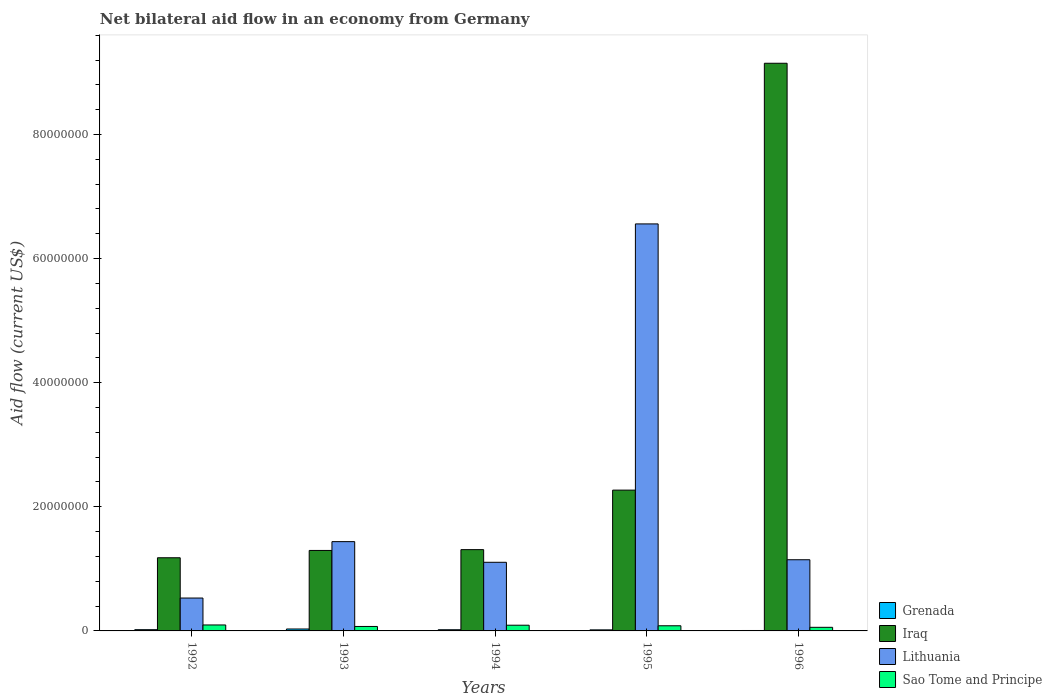How many different coloured bars are there?
Offer a terse response. 4. How many groups of bars are there?
Offer a very short reply. 5. Are the number of bars per tick equal to the number of legend labels?
Your answer should be very brief. Yes. How many bars are there on the 1st tick from the right?
Keep it short and to the point. 4. What is the label of the 1st group of bars from the left?
Keep it short and to the point. 1992. In how many cases, is the number of bars for a given year not equal to the number of legend labels?
Ensure brevity in your answer.  0. What is the net bilateral aid flow in Lithuania in 1994?
Provide a succinct answer. 1.11e+07. Across all years, what is the maximum net bilateral aid flow in Sao Tome and Principe?
Keep it short and to the point. 9.60e+05. Across all years, what is the minimum net bilateral aid flow in Sao Tome and Principe?
Offer a very short reply. 5.80e+05. What is the total net bilateral aid flow in Lithuania in the graph?
Provide a short and direct response. 1.08e+08. What is the difference between the net bilateral aid flow in Lithuania in 1994 and that in 1996?
Offer a very short reply. -4.10e+05. What is the difference between the net bilateral aid flow in Sao Tome and Principe in 1996 and the net bilateral aid flow in Grenada in 1994?
Give a very brief answer. 3.90e+05. What is the average net bilateral aid flow in Sao Tome and Principe per year?
Your response must be concise. 8.02e+05. In the year 1994, what is the difference between the net bilateral aid flow in Grenada and net bilateral aid flow in Sao Tome and Principe?
Keep it short and to the point. -7.30e+05. What is the ratio of the net bilateral aid flow in Lithuania in 1993 to that in 1996?
Your answer should be compact. 1.25. Is the net bilateral aid flow in Grenada in 1992 less than that in 1993?
Your response must be concise. Yes. Is the difference between the net bilateral aid flow in Grenada in 1994 and 1995 greater than the difference between the net bilateral aid flow in Sao Tome and Principe in 1994 and 1995?
Offer a very short reply. No. What is the difference between the highest and the second highest net bilateral aid flow in Lithuania?
Provide a short and direct response. 5.12e+07. What is the difference between the highest and the lowest net bilateral aid flow in Sao Tome and Principe?
Give a very brief answer. 3.80e+05. Is it the case that in every year, the sum of the net bilateral aid flow in Sao Tome and Principe and net bilateral aid flow in Lithuania is greater than the sum of net bilateral aid flow in Iraq and net bilateral aid flow in Grenada?
Your answer should be compact. Yes. What does the 2nd bar from the left in 1994 represents?
Provide a short and direct response. Iraq. What does the 4th bar from the right in 1995 represents?
Ensure brevity in your answer.  Grenada. Where does the legend appear in the graph?
Offer a very short reply. Bottom right. What is the title of the graph?
Offer a very short reply. Net bilateral aid flow in an economy from Germany. Does "Central African Republic" appear as one of the legend labels in the graph?
Give a very brief answer. No. What is the label or title of the Y-axis?
Keep it short and to the point. Aid flow (current US$). What is the Aid flow (current US$) of Grenada in 1992?
Your answer should be compact. 2.00e+05. What is the Aid flow (current US$) of Iraq in 1992?
Provide a short and direct response. 1.18e+07. What is the Aid flow (current US$) in Lithuania in 1992?
Ensure brevity in your answer.  5.30e+06. What is the Aid flow (current US$) of Sao Tome and Principe in 1992?
Keep it short and to the point. 9.60e+05. What is the Aid flow (current US$) in Iraq in 1993?
Keep it short and to the point. 1.30e+07. What is the Aid flow (current US$) in Lithuania in 1993?
Your answer should be compact. 1.44e+07. What is the Aid flow (current US$) of Sao Tome and Principe in 1993?
Your response must be concise. 7.20e+05. What is the Aid flow (current US$) of Grenada in 1994?
Your response must be concise. 1.90e+05. What is the Aid flow (current US$) in Iraq in 1994?
Your response must be concise. 1.31e+07. What is the Aid flow (current US$) of Lithuania in 1994?
Give a very brief answer. 1.11e+07. What is the Aid flow (current US$) in Sao Tome and Principe in 1994?
Your response must be concise. 9.20e+05. What is the Aid flow (current US$) in Iraq in 1995?
Ensure brevity in your answer.  2.27e+07. What is the Aid flow (current US$) in Lithuania in 1995?
Give a very brief answer. 6.56e+07. What is the Aid flow (current US$) of Sao Tome and Principe in 1995?
Your response must be concise. 8.30e+05. What is the Aid flow (current US$) of Grenada in 1996?
Keep it short and to the point. 7.00e+04. What is the Aid flow (current US$) in Iraq in 1996?
Provide a succinct answer. 9.15e+07. What is the Aid flow (current US$) of Lithuania in 1996?
Offer a very short reply. 1.15e+07. What is the Aid flow (current US$) of Sao Tome and Principe in 1996?
Provide a succinct answer. 5.80e+05. Across all years, what is the maximum Aid flow (current US$) of Iraq?
Your answer should be compact. 9.15e+07. Across all years, what is the maximum Aid flow (current US$) in Lithuania?
Ensure brevity in your answer.  6.56e+07. Across all years, what is the maximum Aid flow (current US$) of Sao Tome and Principe?
Keep it short and to the point. 9.60e+05. Across all years, what is the minimum Aid flow (current US$) of Iraq?
Your answer should be very brief. 1.18e+07. Across all years, what is the minimum Aid flow (current US$) of Lithuania?
Keep it short and to the point. 5.30e+06. Across all years, what is the minimum Aid flow (current US$) in Sao Tome and Principe?
Offer a terse response. 5.80e+05. What is the total Aid flow (current US$) of Grenada in the graph?
Keep it short and to the point. 9.40e+05. What is the total Aid flow (current US$) in Iraq in the graph?
Keep it short and to the point. 1.52e+08. What is the total Aid flow (current US$) in Lithuania in the graph?
Make the answer very short. 1.08e+08. What is the total Aid flow (current US$) in Sao Tome and Principe in the graph?
Offer a very short reply. 4.01e+06. What is the difference between the Aid flow (current US$) of Iraq in 1992 and that in 1993?
Your answer should be compact. -1.18e+06. What is the difference between the Aid flow (current US$) of Lithuania in 1992 and that in 1993?
Your response must be concise. -9.09e+06. What is the difference between the Aid flow (current US$) of Sao Tome and Principe in 1992 and that in 1993?
Offer a terse response. 2.40e+05. What is the difference between the Aid flow (current US$) in Iraq in 1992 and that in 1994?
Make the answer very short. -1.31e+06. What is the difference between the Aid flow (current US$) in Lithuania in 1992 and that in 1994?
Keep it short and to the point. -5.76e+06. What is the difference between the Aid flow (current US$) of Sao Tome and Principe in 1992 and that in 1994?
Give a very brief answer. 4.00e+04. What is the difference between the Aid flow (current US$) of Grenada in 1992 and that in 1995?
Keep it short and to the point. 3.00e+04. What is the difference between the Aid flow (current US$) in Iraq in 1992 and that in 1995?
Offer a very short reply. -1.09e+07. What is the difference between the Aid flow (current US$) of Lithuania in 1992 and that in 1995?
Provide a short and direct response. -6.03e+07. What is the difference between the Aid flow (current US$) in Sao Tome and Principe in 1992 and that in 1995?
Offer a very short reply. 1.30e+05. What is the difference between the Aid flow (current US$) in Grenada in 1992 and that in 1996?
Keep it short and to the point. 1.30e+05. What is the difference between the Aid flow (current US$) of Iraq in 1992 and that in 1996?
Offer a very short reply. -7.97e+07. What is the difference between the Aid flow (current US$) in Lithuania in 1992 and that in 1996?
Ensure brevity in your answer.  -6.17e+06. What is the difference between the Aid flow (current US$) of Grenada in 1993 and that in 1994?
Offer a terse response. 1.20e+05. What is the difference between the Aid flow (current US$) of Iraq in 1993 and that in 1994?
Your answer should be very brief. -1.30e+05. What is the difference between the Aid flow (current US$) of Lithuania in 1993 and that in 1994?
Offer a terse response. 3.33e+06. What is the difference between the Aid flow (current US$) of Sao Tome and Principe in 1993 and that in 1994?
Your response must be concise. -2.00e+05. What is the difference between the Aid flow (current US$) in Iraq in 1993 and that in 1995?
Give a very brief answer. -9.72e+06. What is the difference between the Aid flow (current US$) in Lithuania in 1993 and that in 1995?
Provide a succinct answer. -5.12e+07. What is the difference between the Aid flow (current US$) in Iraq in 1993 and that in 1996?
Provide a succinct answer. -7.85e+07. What is the difference between the Aid flow (current US$) of Lithuania in 1993 and that in 1996?
Provide a succinct answer. 2.92e+06. What is the difference between the Aid flow (current US$) in Grenada in 1994 and that in 1995?
Make the answer very short. 2.00e+04. What is the difference between the Aid flow (current US$) of Iraq in 1994 and that in 1995?
Make the answer very short. -9.59e+06. What is the difference between the Aid flow (current US$) in Lithuania in 1994 and that in 1995?
Your answer should be very brief. -5.45e+07. What is the difference between the Aid flow (current US$) in Sao Tome and Principe in 1994 and that in 1995?
Your answer should be compact. 9.00e+04. What is the difference between the Aid flow (current US$) of Grenada in 1994 and that in 1996?
Provide a succinct answer. 1.20e+05. What is the difference between the Aid flow (current US$) of Iraq in 1994 and that in 1996?
Your response must be concise. -7.84e+07. What is the difference between the Aid flow (current US$) in Lithuania in 1994 and that in 1996?
Ensure brevity in your answer.  -4.10e+05. What is the difference between the Aid flow (current US$) of Sao Tome and Principe in 1994 and that in 1996?
Your answer should be compact. 3.40e+05. What is the difference between the Aid flow (current US$) of Iraq in 1995 and that in 1996?
Your response must be concise. -6.88e+07. What is the difference between the Aid flow (current US$) in Lithuania in 1995 and that in 1996?
Your answer should be very brief. 5.41e+07. What is the difference between the Aid flow (current US$) of Grenada in 1992 and the Aid flow (current US$) of Iraq in 1993?
Your response must be concise. -1.28e+07. What is the difference between the Aid flow (current US$) of Grenada in 1992 and the Aid flow (current US$) of Lithuania in 1993?
Offer a very short reply. -1.42e+07. What is the difference between the Aid flow (current US$) of Grenada in 1992 and the Aid flow (current US$) of Sao Tome and Principe in 1993?
Keep it short and to the point. -5.20e+05. What is the difference between the Aid flow (current US$) in Iraq in 1992 and the Aid flow (current US$) in Lithuania in 1993?
Offer a terse response. -2.60e+06. What is the difference between the Aid flow (current US$) of Iraq in 1992 and the Aid flow (current US$) of Sao Tome and Principe in 1993?
Give a very brief answer. 1.11e+07. What is the difference between the Aid flow (current US$) of Lithuania in 1992 and the Aid flow (current US$) of Sao Tome and Principe in 1993?
Offer a terse response. 4.58e+06. What is the difference between the Aid flow (current US$) of Grenada in 1992 and the Aid flow (current US$) of Iraq in 1994?
Make the answer very short. -1.29e+07. What is the difference between the Aid flow (current US$) of Grenada in 1992 and the Aid flow (current US$) of Lithuania in 1994?
Provide a succinct answer. -1.09e+07. What is the difference between the Aid flow (current US$) of Grenada in 1992 and the Aid flow (current US$) of Sao Tome and Principe in 1994?
Give a very brief answer. -7.20e+05. What is the difference between the Aid flow (current US$) in Iraq in 1992 and the Aid flow (current US$) in Lithuania in 1994?
Your answer should be compact. 7.30e+05. What is the difference between the Aid flow (current US$) of Iraq in 1992 and the Aid flow (current US$) of Sao Tome and Principe in 1994?
Your answer should be very brief. 1.09e+07. What is the difference between the Aid flow (current US$) in Lithuania in 1992 and the Aid flow (current US$) in Sao Tome and Principe in 1994?
Provide a succinct answer. 4.38e+06. What is the difference between the Aid flow (current US$) of Grenada in 1992 and the Aid flow (current US$) of Iraq in 1995?
Give a very brief answer. -2.25e+07. What is the difference between the Aid flow (current US$) of Grenada in 1992 and the Aid flow (current US$) of Lithuania in 1995?
Offer a terse response. -6.54e+07. What is the difference between the Aid flow (current US$) of Grenada in 1992 and the Aid flow (current US$) of Sao Tome and Principe in 1995?
Your response must be concise. -6.30e+05. What is the difference between the Aid flow (current US$) of Iraq in 1992 and the Aid flow (current US$) of Lithuania in 1995?
Provide a short and direct response. -5.38e+07. What is the difference between the Aid flow (current US$) of Iraq in 1992 and the Aid flow (current US$) of Sao Tome and Principe in 1995?
Provide a short and direct response. 1.10e+07. What is the difference between the Aid flow (current US$) of Lithuania in 1992 and the Aid flow (current US$) of Sao Tome and Principe in 1995?
Keep it short and to the point. 4.47e+06. What is the difference between the Aid flow (current US$) of Grenada in 1992 and the Aid flow (current US$) of Iraq in 1996?
Your response must be concise. -9.13e+07. What is the difference between the Aid flow (current US$) of Grenada in 1992 and the Aid flow (current US$) of Lithuania in 1996?
Your answer should be compact. -1.13e+07. What is the difference between the Aid flow (current US$) of Grenada in 1992 and the Aid flow (current US$) of Sao Tome and Principe in 1996?
Your answer should be very brief. -3.80e+05. What is the difference between the Aid flow (current US$) of Iraq in 1992 and the Aid flow (current US$) of Sao Tome and Principe in 1996?
Make the answer very short. 1.12e+07. What is the difference between the Aid flow (current US$) of Lithuania in 1992 and the Aid flow (current US$) of Sao Tome and Principe in 1996?
Provide a short and direct response. 4.72e+06. What is the difference between the Aid flow (current US$) of Grenada in 1993 and the Aid flow (current US$) of Iraq in 1994?
Your answer should be compact. -1.28e+07. What is the difference between the Aid flow (current US$) of Grenada in 1993 and the Aid flow (current US$) of Lithuania in 1994?
Your answer should be compact. -1.08e+07. What is the difference between the Aid flow (current US$) in Grenada in 1993 and the Aid flow (current US$) in Sao Tome and Principe in 1994?
Offer a terse response. -6.10e+05. What is the difference between the Aid flow (current US$) of Iraq in 1993 and the Aid flow (current US$) of Lithuania in 1994?
Offer a terse response. 1.91e+06. What is the difference between the Aid flow (current US$) of Iraq in 1993 and the Aid flow (current US$) of Sao Tome and Principe in 1994?
Offer a terse response. 1.20e+07. What is the difference between the Aid flow (current US$) of Lithuania in 1993 and the Aid flow (current US$) of Sao Tome and Principe in 1994?
Give a very brief answer. 1.35e+07. What is the difference between the Aid flow (current US$) of Grenada in 1993 and the Aid flow (current US$) of Iraq in 1995?
Provide a short and direct response. -2.24e+07. What is the difference between the Aid flow (current US$) in Grenada in 1993 and the Aid flow (current US$) in Lithuania in 1995?
Your response must be concise. -6.53e+07. What is the difference between the Aid flow (current US$) of Grenada in 1993 and the Aid flow (current US$) of Sao Tome and Principe in 1995?
Make the answer very short. -5.20e+05. What is the difference between the Aid flow (current US$) of Iraq in 1993 and the Aid flow (current US$) of Lithuania in 1995?
Provide a succinct answer. -5.26e+07. What is the difference between the Aid flow (current US$) of Iraq in 1993 and the Aid flow (current US$) of Sao Tome and Principe in 1995?
Your response must be concise. 1.21e+07. What is the difference between the Aid flow (current US$) of Lithuania in 1993 and the Aid flow (current US$) of Sao Tome and Principe in 1995?
Provide a short and direct response. 1.36e+07. What is the difference between the Aid flow (current US$) in Grenada in 1993 and the Aid flow (current US$) in Iraq in 1996?
Give a very brief answer. -9.12e+07. What is the difference between the Aid flow (current US$) in Grenada in 1993 and the Aid flow (current US$) in Lithuania in 1996?
Offer a very short reply. -1.12e+07. What is the difference between the Aid flow (current US$) of Iraq in 1993 and the Aid flow (current US$) of Lithuania in 1996?
Your answer should be compact. 1.50e+06. What is the difference between the Aid flow (current US$) of Iraq in 1993 and the Aid flow (current US$) of Sao Tome and Principe in 1996?
Your response must be concise. 1.24e+07. What is the difference between the Aid flow (current US$) in Lithuania in 1993 and the Aid flow (current US$) in Sao Tome and Principe in 1996?
Offer a terse response. 1.38e+07. What is the difference between the Aid flow (current US$) in Grenada in 1994 and the Aid flow (current US$) in Iraq in 1995?
Provide a succinct answer. -2.25e+07. What is the difference between the Aid flow (current US$) in Grenada in 1994 and the Aid flow (current US$) in Lithuania in 1995?
Your answer should be compact. -6.54e+07. What is the difference between the Aid flow (current US$) in Grenada in 1994 and the Aid flow (current US$) in Sao Tome and Principe in 1995?
Offer a very short reply. -6.40e+05. What is the difference between the Aid flow (current US$) of Iraq in 1994 and the Aid flow (current US$) of Lithuania in 1995?
Offer a very short reply. -5.25e+07. What is the difference between the Aid flow (current US$) in Iraq in 1994 and the Aid flow (current US$) in Sao Tome and Principe in 1995?
Your answer should be very brief. 1.23e+07. What is the difference between the Aid flow (current US$) of Lithuania in 1994 and the Aid flow (current US$) of Sao Tome and Principe in 1995?
Provide a short and direct response. 1.02e+07. What is the difference between the Aid flow (current US$) in Grenada in 1994 and the Aid flow (current US$) in Iraq in 1996?
Keep it short and to the point. -9.13e+07. What is the difference between the Aid flow (current US$) in Grenada in 1994 and the Aid flow (current US$) in Lithuania in 1996?
Your answer should be compact. -1.13e+07. What is the difference between the Aid flow (current US$) of Grenada in 1994 and the Aid flow (current US$) of Sao Tome and Principe in 1996?
Give a very brief answer. -3.90e+05. What is the difference between the Aid flow (current US$) in Iraq in 1994 and the Aid flow (current US$) in Lithuania in 1996?
Keep it short and to the point. 1.63e+06. What is the difference between the Aid flow (current US$) of Iraq in 1994 and the Aid flow (current US$) of Sao Tome and Principe in 1996?
Keep it short and to the point. 1.25e+07. What is the difference between the Aid flow (current US$) in Lithuania in 1994 and the Aid flow (current US$) in Sao Tome and Principe in 1996?
Ensure brevity in your answer.  1.05e+07. What is the difference between the Aid flow (current US$) in Grenada in 1995 and the Aid flow (current US$) in Iraq in 1996?
Give a very brief answer. -9.13e+07. What is the difference between the Aid flow (current US$) of Grenada in 1995 and the Aid flow (current US$) of Lithuania in 1996?
Give a very brief answer. -1.13e+07. What is the difference between the Aid flow (current US$) of Grenada in 1995 and the Aid flow (current US$) of Sao Tome and Principe in 1996?
Your answer should be compact. -4.10e+05. What is the difference between the Aid flow (current US$) in Iraq in 1995 and the Aid flow (current US$) in Lithuania in 1996?
Offer a terse response. 1.12e+07. What is the difference between the Aid flow (current US$) in Iraq in 1995 and the Aid flow (current US$) in Sao Tome and Principe in 1996?
Give a very brief answer. 2.21e+07. What is the difference between the Aid flow (current US$) in Lithuania in 1995 and the Aid flow (current US$) in Sao Tome and Principe in 1996?
Make the answer very short. 6.50e+07. What is the average Aid flow (current US$) in Grenada per year?
Keep it short and to the point. 1.88e+05. What is the average Aid flow (current US$) in Iraq per year?
Offer a very short reply. 3.04e+07. What is the average Aid flow (current US$) of Lithuania per year?
Provide a short and direct response. 2.16e+07. What is the average Aid flow (current US$) in Sao Tome and Principe per year?
Your answer should be very brief. 8.02e+05. In the year 1992, what is the difference between the Aid flow (current US$) in Grenada and Aid flow (current US$) in Iraq?
Give a very brief answer. -1.16e+07. In the year 1992, what is the difference between the Aid flow (current US$) of Grenada and Aid flow (current US$) of Lithuania?
Offer a terse response. -5.10e+06. In the year 1992, what is the difference between the Aid flow (current US$) of Grenada and Aid flow (current US$) of Sao Tome and Principe?
Keep it short and to the point. -7.60e+05. In the year 1992, what is the difference between the Aid flow (current US$) of Iraq and Aid flow (current US$) of Lithuania?
Keep it short and to the point. 6.49e+06. In the year 1992, what is the difference between the Aid flow (current US$) in Iraq and Aid flow (current US$) in Sao Tome and Principe?
Make the answer very short. 1.08e+07. In the year 1992, what is the difference between the Aid flow (current US$) in Lithuania and Aid flow (current US$) in Sao Tome and Principe?
Provide a succinct answer. 4.34e+06. In the year 1993, what is the difference between the Aid flow (current US$) in Grenada and Aid flow (current US$) in Iraq?
Offer a very short reply. -1.27e+07. In the year 1993, what is the difference between the Aid flow (current US$) of Grenada and Aid flow (current US$) of Lithuania?
Provide a succinct answer. -1.41e+07. In the year 1993, what is the difference between the Aid flow (current US$) in Grenada and Aid flow (current US$) in Sao Tome and Principe?
Give a very brief answer. -4.10e+05. In the year 1993, what is the difference between the Aid flow (current US$) in Iraq and Aid flow (current US$) in Lithuania?
Provide a succinct answer. -1.42e+06. In the year 1993, what is the difference between the Aid flow (current US$) of Iraq and Aid flow (current US$) of Sao Tome and Principe?
Give a very brief answer. 1.22e+07. In the year 1993, what is the difference between the Aid flow (current US$) in Lithuania and Aid flow (current US$) in Sao Tome and Principe?
Your response must be concise. 1.37e+07. In the year 1994, what is the difference between the Aid flow (current US$) in Grenada and Aid flow (current US$) in Iraq?
Provide a succinct answer. -1.29e+07. In the year 1994, what is the difference between the Aid flow (current US$) of Grenada and Aid flow (current US$) of Lithuania?
Ensure brevity in your answer.  -1.09e+07. In the year 1994, what is the difference between the Aid flow (current US$) in Grenada and Aid flow (current US$) in Sao Tome and Principe?
Ensure brevity in your answer.  -7.30e+05. In the year 1994, what is the difference between the Aid flow (current US$) in Iraq and Aid flow (current US$) in Lithuania?
Make the answer very short. 2.04e+06. In the year 1994, what is the difference between the Aid flow (current US$) of Iraq and Aid flow (current US$) of Sao Tome and Principe?
Your response must be concise. 1.22e+07. In the year 1994, what is the difference between the Aid flow (current US$) of Lithuania and Aid flow (current US$) of Sao Tome and Principe?
Make the answer very short. 1.01e+07. In the year 1995, what is the difference between the Aid flow (current US$) of Grenada and Aid flow (current US$) of Iraq?
Make the answer very short. -2.25e+07. In the year 1995, what is the difference between the Aid flow (current US$) of Grenada and Aid flow (current US$) of Lithuania?
Provide a succinct answer. -6.54e+07. In the year 1995, what is the difference between the Aid flow (current US$) in Grenada and Aid flow (current US$) in Sao Tome and Principe?
Offer a very short reply. -6.60e+05. In the year 1995, what is the difference between the Aid flow (current US$) of Iraq and Aid flow (current US$) of Lithuania?
Your answer should be very brief. -4.29e+07. In the year 1995, what is the difference between the Aid flow (current US$) of Iraq and Aid flow (current US$) of Sao Tome and Principe?
Provide a succinct answer. 2.19e+07. In the year 1995, what is the difference between the Aid flow (current US$) of Lithuania and Aid flow (current US$) of Sao Tome and Principe?
Provide a succinct answer. 6.48e+07. In the year 1996, what is the difference between the Aid flow (current US$) in Grenada and Aid flow (current US$) in Iraq?
Provide a short and direct response. -9.14e+07. In the year 1996, what is the difference between the Aid flow (current US$) in Grenada and Aid flow (current US$) in Lithuania?
Offer a terse response. -1.14e+07. In the year 1996, what is the difference between the Aid flow (current US$) of Grenada and Aid flow (current US$) of Sao Tome and Principe?
Provide a short and direct response. -5.10e+05. In the year 1996, what is the difference between the Aid flow (current US$) in Iraq and Aid flow (current US$) in Lithuania?
Offer a terse response. 8.00e+07. In the year 1996, what is the difference between the Aid flow (current US$) of Iraq and Aid flow (current US$) of Sao Tome and Principe?
Your answer should be compact. 9.09e+07. In the year 1996, what is the difference between the Aid flow (current US$) of Lithuania and Aid flow (current US$) of Sao Tome and Principe?
Keep it short and to the point. 1.09e+07. What is the ratio of the Aid flow (current US$) in Grenada in 1992 to that in 1993?
Keep it short and to the point. 0.65. What is the ratio of the Aid flow (current US$) in Iraq in 1992 to that in 1993?
Ensure brevity in your answer.  0.91. What is the ratio of the Aid flow (current US$) in Lithuania in 1992 to that in 1993?
Ensure brevity in your answer.  0.37. What is the ratio of the Aid flow (current US$) in Grenada in 1992 to that in 1994?
Offer a terse response. 1.05. What is the ratio of the Aid flow (current US$) of Iraq in 1992 to that in 1994?
Offer a terse response. 0.9. What is the ratio of the Aid flow (current US$) in Lithuania in 1992 to that in 1994?
Provide a short and direct response. 0.48. What is the ratio of the Aid flow (current US$) in Sao Tome and Principe in 1992 to that in 1994?
Give a very brief answer. 1.04. What is the ratio of the Aid flow (current US$) in Grenada in 1992 to that in 1995?
Make the answer very short. 1.18. What is the ratio of the Aid flow (current US$) of Iraq in 1992 to that in 1995?
Your response must be concise. 0.52. What is the ratio of the Aid flow (current US$) in Lithuania in 1992 to that in 1995?
Your response must be concise. 0.08. What is the ratio of the Aid flow (current US$) in Sao Tome and Principe in 1992 to that in 1995?
Make the answer very short. 1.16. What is the ratio of the Aid flow (current US$) of Grenada in 1992 to that in 1996?
Your response must be concise. 2.86. What is the ratio of the Aid flow (current US$) of Iraq in 1992 to that in 1996?
Your answer should be compact. 0.13. What is the ratio of the Aid flow (current US$) in Lithuania in 1992 to that in 1996?
Your response must be concise. 0.46. What is the ratio of the Aid flow (current US$) in Sao Tome and Principe in 1992 to that in 1996?
Give a very brief answer. 1.66. What is the ratio of the Aid flow (current US$) in Grenada in 1993 to that in 1994?
Ensure brevity in your answer.  1.63. What is the ratio of the Aid flow (current US$) in Iraq in 1993 to that in 1994?
Provide a succinct answer. 0.99. What is the ratio of the Aid flow (current US$) of Lithuania in 1993 to that in 1994?
Give a very brief answer. 1.3. What is the ratio of the Aid flow (current US$) in Sao Tome and Principe in 1993 to that in 1994?
Make the answer very short. 0.78. What is the ratio of the Aid flow (current US$) of Grenada in 1993 to that in 1995?
Ensure brevity in your answer.  1.82. What is the ratio of the Aid flow (current US$) in Iraq in 1993 to that in 1995?
Offer a terse response. 0.57. What is the ratio of the Aid flow (current US$) of Lithuania in 1993 to that in 1995?
Your answer should be very brief. 0.22. What is the ratio of the Aid flow (current US$) of Sao Tome and Principe in 1993 to that in 1995?
Ensure brevity in your answer.  0.87. What is the ratio of the Aid flow (current US$) of Grenada in 1993 to that in 1996?
Your answer should be very brief. 4.43. What is the ratio of the Aid flow (current US$) of Iraq in 1993 to that in 1996?
Offer a terse response. 0.14. What is the ratio of the Aid flow (current US$) of Lithuania in 1993 to that in 1996?
Your answer should be compact. 1.25. What is the ratio of the Aid flow (current US$) of Sao Tome and Principe in 1993 to that in 1996?
Give a very brief answer. 1.24. What is the ratio of the Aid flow (current US$) of Grenada in 1994 to that in 1995?
Provide a short and direct response. 1.12. What is the ratio of the Aid flow (current US$) of Iraq in 1994 to that in 1995?
Provide a succinct answer. 0.58. What is the ratio of the Aid flow (current US$) in Lithuania in 1994 to that in 1995?
Ensure brevity in your answer.  0.17. What is the ratio of the Aid flow (current US$) in Sao Tome and Principe in 1994 to that in 1995?
Your response must be concise. 1.11. What is the ratio of the Aid flow (current US$) in Grenada in 1994 to that in 1996?
Your answer should be compact. 2.71. What is the ratio of the Aid flow (current US$) of Iraq in 1994 to that in 1996?
Ensure brevity in your answer.  0.14. What is the ratio of the Aid flow (current US$) of Sao Tome and Principe in 1994 to that in 1996?
Ensure brevity in your answer.  1.59. What is the ratio of the Aid flow (current US$) in Grenada in 1995 to that in 1996?
Offer a terse response. 2.43. What is the ratio of the Aid flow (current US$) of Iraq in 1995 to that in 1996?
Your response must be concise. 0.25. What is the ratio of the Aid flow (current US$) in Lithuania in 1995 to that in 1996?
Give a very brief answer. 5.72. What is the ratio of the Aid flow (current US$) of Sao Tome and Principe in 1995 to that in 1996?
Ensure brevity in your answer.  1.43. What is the difference between the highest and the second highest Aid flow (current US$) in Iraq?
Provide a short and direct response. 6.88e+07. What is the difference between the highest and the second highest Aid flow (current US$) in Lithuania?
Ensure brevity in your answer.  5.12e+07. What is the difference between the highest and the lowest Aid flow (current US$) in Grenada?
Provide a succinct answer. 2.40e+05. What is the difference between the highest and the lowest Aid flow (current US$) in Iraq?
Your response must be concise. 7.97e+07. What is the difference between the highest and the lowest Aid flow (current US$) of Lithuania?
Your answer should be very brief. 6.03e+07. 